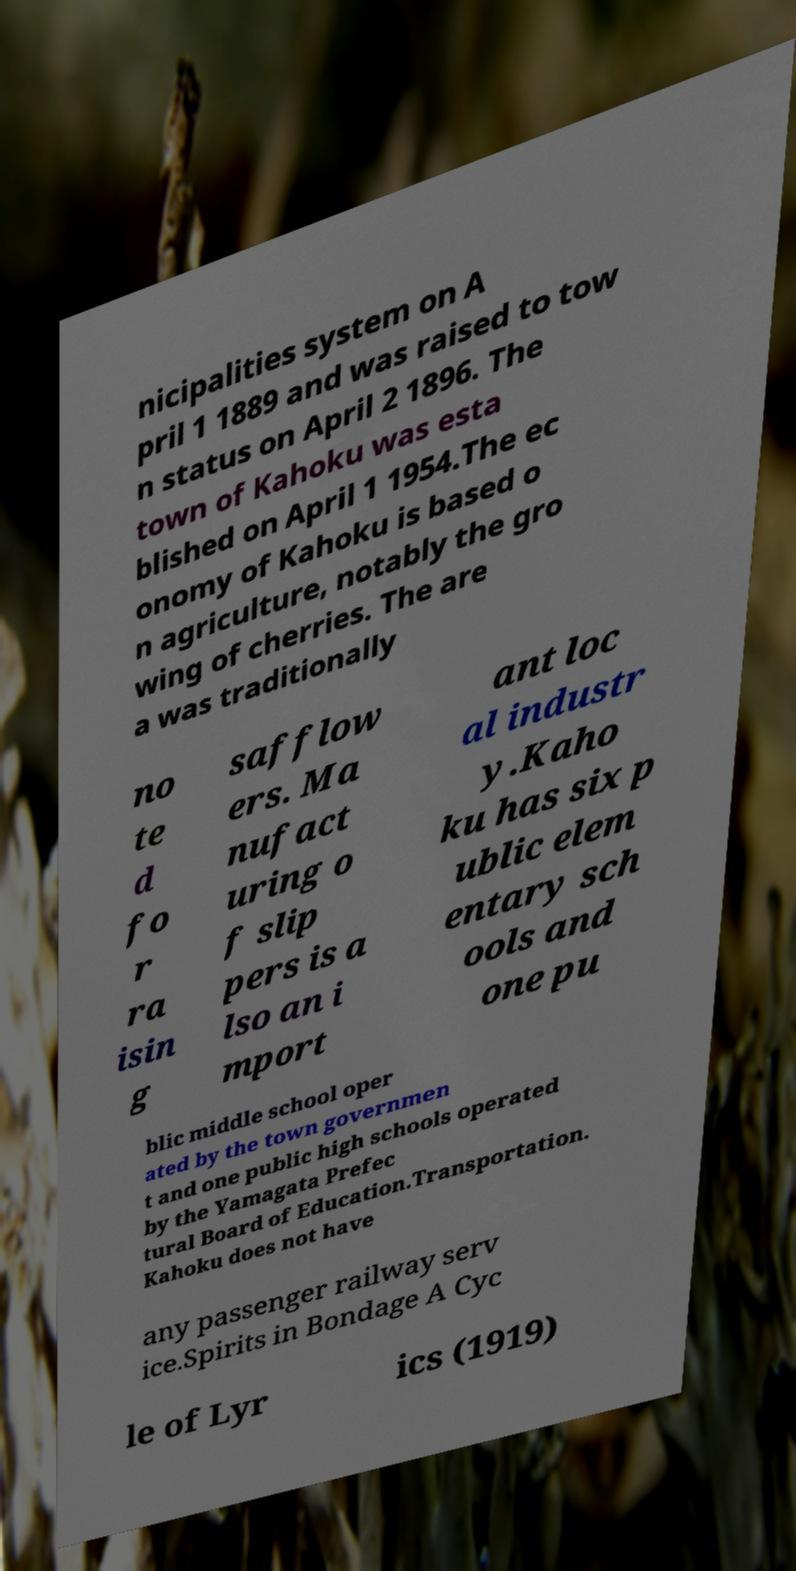Can you accurately transcribe the text from the provided image for me? nicipalities system on A pril 1 1889 and was raised to tow n status on April 2 1896. The town of Kahoku was esta blished on April 1 1954.The ec onomy of Kahoku is based o n agriculture, notably the gro wing of cherries. The are a was traditionally no te d fo r ra isin g safflow ers. Ma nufact uring o f slip pers is a lso an i mport ant loc al industr y.Kaho ku has six p ublic elem entary sch ools and one pu blic middle school oper ated by the town governmen t and one public high schools operated by the Yamagata Prefec tural Board of Education.Transportation. Kahoku does not have any passenger railway serv ice.Spirits in Bondage A Cyc le of Lyr ics (1919) 